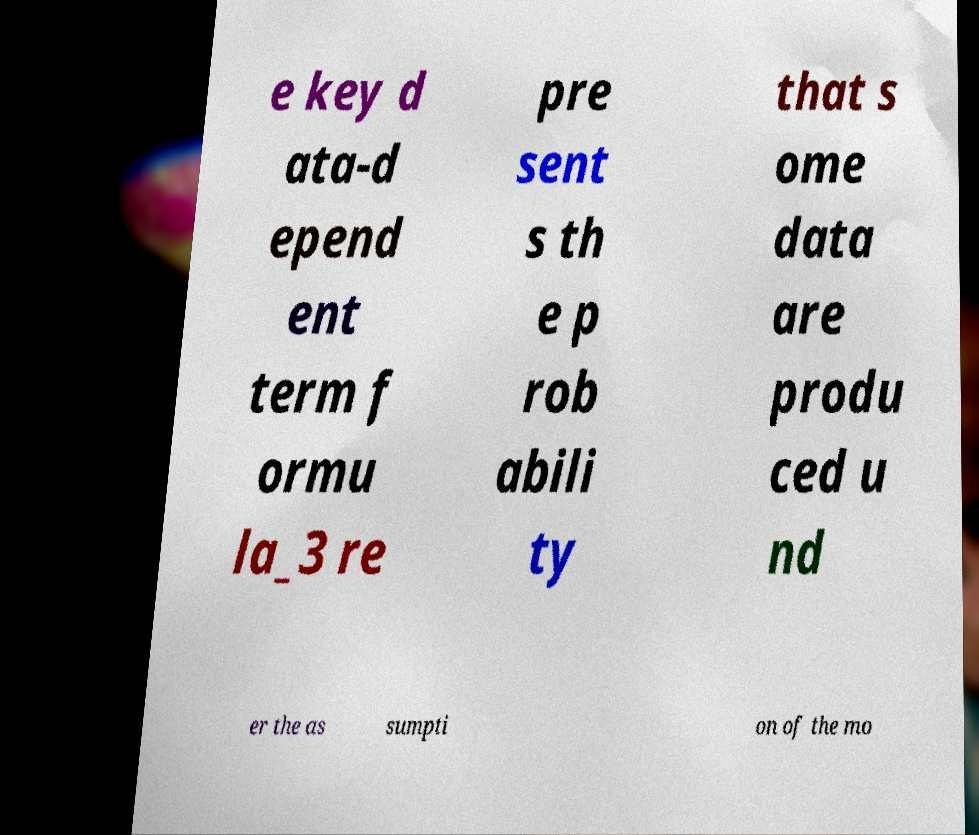Please identify and transcribe the text found in this image. e key d ata-d epend ent term f ormu la_3 re pre sent s th e p rob abili ty that s ome data are produ ced u nd er the as sumpti on of the mo 